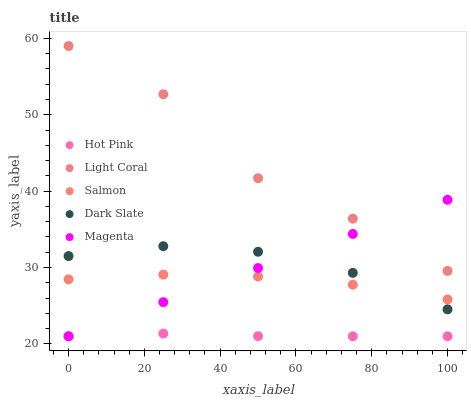Does Hot Pink have the minimum area under the curve?
Answer yes or no. Yes. Does Light Coral have the maximum area under the curve?
Answer yes or no. Yes. Does Dark Slate have the minimum area under the curve?
Answer yes or no. No. Does Dark Slate have the maximum area under the curve?
Answer yes or no. No. Is Magenta the smoothest?
Answer yes or no. Yes. Is Light Coral the roughest?
Answer yes or no. Yes. Is Dark Slate the smoothest?
Answer yes or no. No. Is Dark Slate the roughest?
Answer yes or no. No. Does Magenta have the lowest value?
Answer yes or no. Yes. Does Dark Slate have the lowest value?
Answer yes or no. No. Does Light Coral have the highest value?
Answer yes or no. Yes. Does Dark Slate have the highest value?
Answer yes or no. No. Is Dark Slate less than Light Coral?
Answer yes or no. Yes. Is Light Coral greater than Hot Pink?
Answer yes or no. Yes. Does Hot Pink intersect Magenta?
Answer yes or no. Yes. Is Hot Pink less than Magenta?
Answer yes or no. No. Is Hot Pink greater than Magenta?
Answer yes or no. No. Does Dark Slate intersect Light Coral?
Answer yes or no. No. 